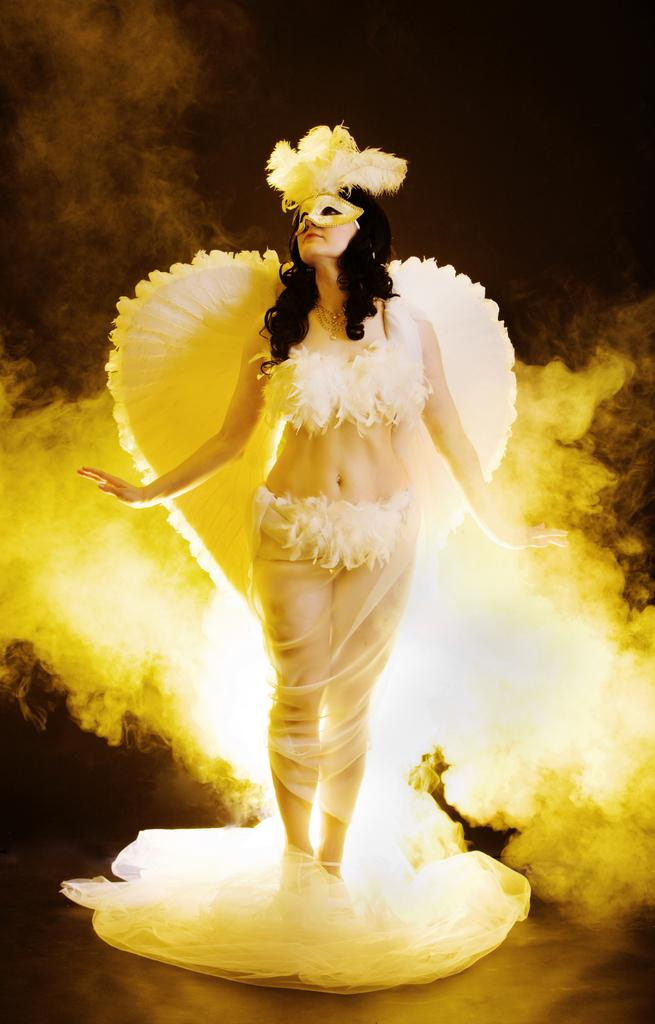Who is the main subject in the image? There is a lady in the image. What is the lady dressed up as? The lady is dressed up like an angel. Where is the bee sitting in the image? There is no bee present in the image. What type of seat is the lady using in the image? The provided facts do not mention a seat, so we cannot determine if the lady is using one. 